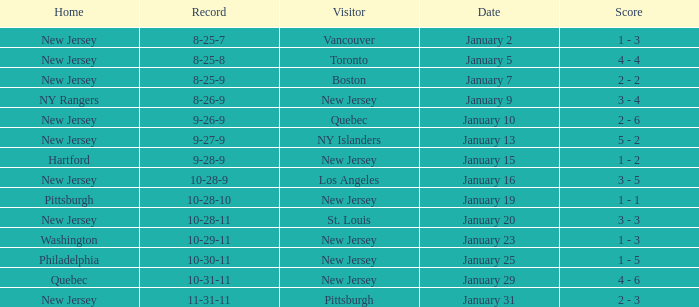What was the date that ended in a record of 8-25-7? January 2. 